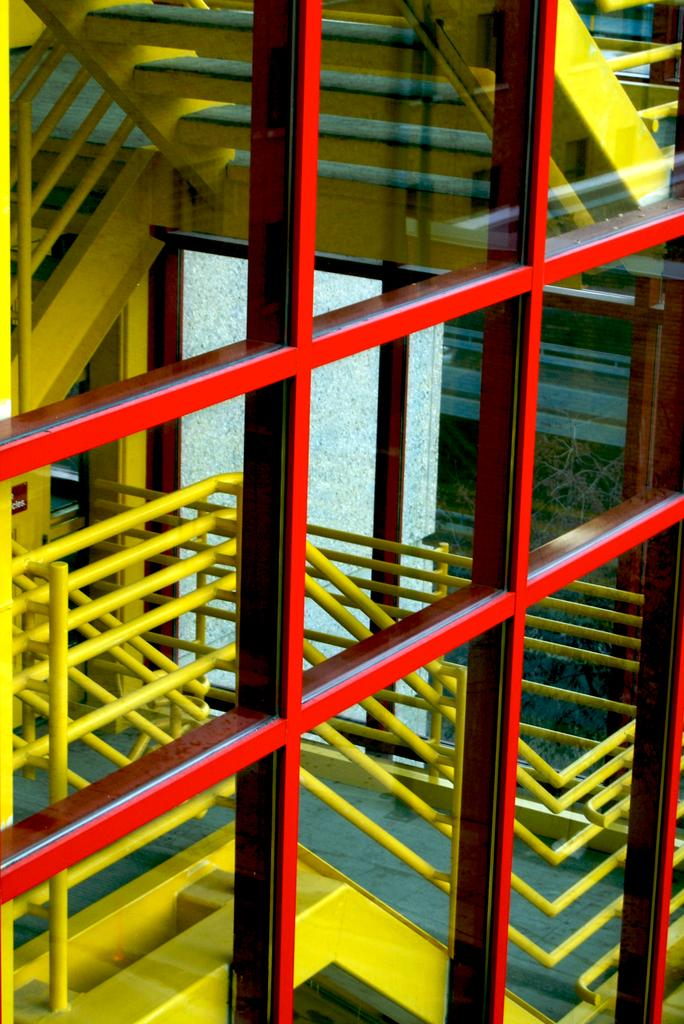What type of structure is present in the image? There are stairs in the image. What are the staircase holders used for? The staircase holders are used to provide support and stability while using the stairs. What type of windows can be seen in the image? There are glass windows in the image. What type of vest is being worn by the person on the stairs in the image? There is no person visible in the image, and therefore no vest can be observed. Is there a baseball game taking place in the image? There is no indication of a baseball game or any sports activity in the image. 